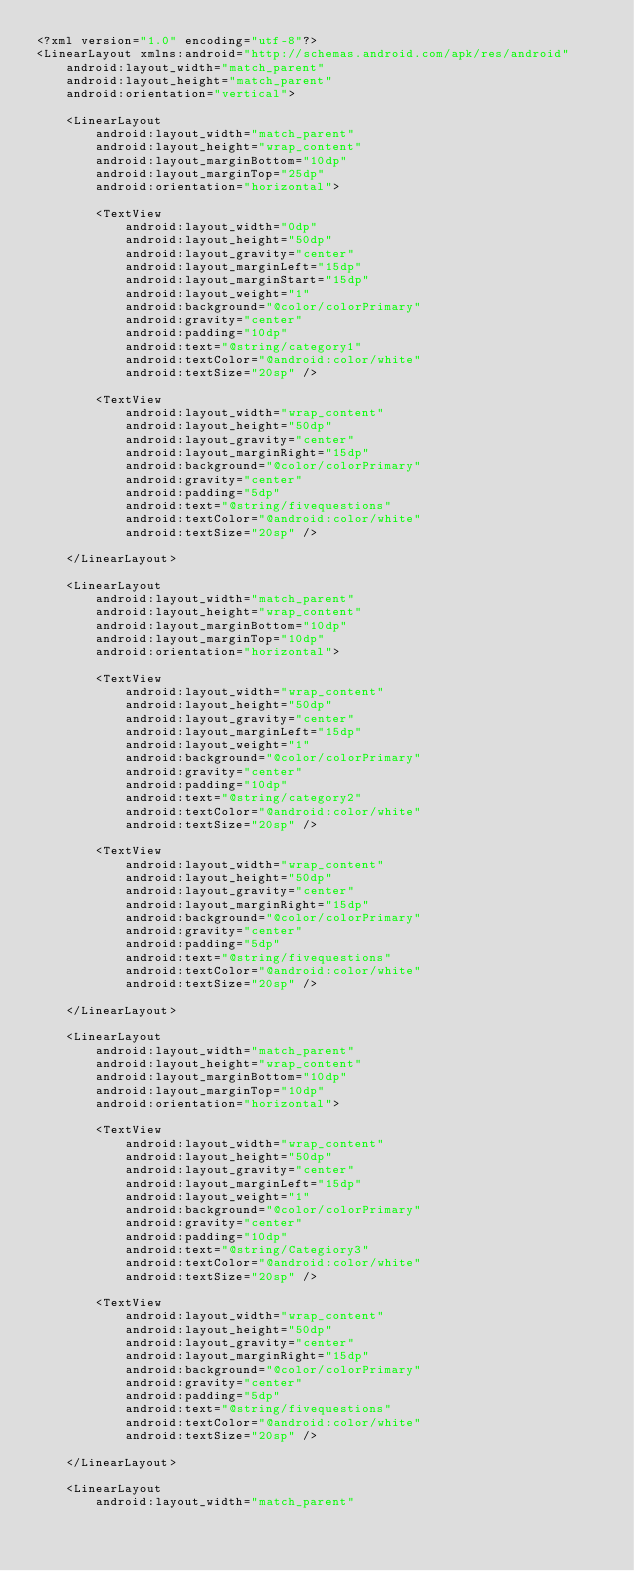<code> <loc_0><loc_0><loc_500><loc_500><_XML_><?xml version="1.0" encoding="utf-8"?>
<LinearLayout xmlns:android="http://schemas.android.com/apk/res/android"
    android:layout_width="match_parent"
    android:layout_height="match_parent"
    android:orientation="vertical">

    <LinearLayout
        android:layout_width="match_parent"
        android:layout_height="wrap_content"
        android:layout_marginBottom="10dp"
        android:layout_marginTop="25dp"
        android:orientation="horizontal">

        <TextView
            android:layout_width="0dp"
            android:layout_height="50dp"
            android:layout_gravity="center"
            android:layout_marginLeft="15dp"
            android:layout_marginStart="15dp"
            android:layout_weight="1"
            android:background="@color/colorPrimary"
            android:gravity="center"
            android:padding="10dp"
            android:text="@string/category1"
            android:textColor="@android:color/white"
            android:textSize="20sp" />

        <TextView
            android:layout_width="wrap_content"
            android:layout_height="50dp"
            android:layout_gravity="center"
            android:layout_marginRight="15dp"
            android:background="@color/colorPrimary"
            android:gravity="center"
            android:padding="5dp"
            android:text="@string/fivequestions"
            android:textColor="@android:color/white"
            android:textSize="20sp" />

    </LinearLayout>

    <LinearLayout
        android:layout_width="match_parent"
        android:layout_height="wrap_content"
        android:layout_marginBottom="10dp"
        android:layout_marginTop="10dp"
        android:orientation="horizontal">

        <TextView
            android:layout_width="wrap_content"
            android:layout_height="50dp"
            android:layout_gravity="center"
            android:layout_marginLeft="15dp"
            android:layout_weight="1"
            android:background="@color/colorPrimary"
            android:gravity="center"
            android:padding="10dp"
            android:text="@string/category2"
            android:textColor="@android:color/white"
            android:textSize="20sp" />

        <TextView
            android:layout_width="wrap_content"
            android:layout_height="50dp"
            android:layout_gravity="center"
            android:layout_marginRight="15dp"
            android:background="@color/colorPrimary"
            android:gravity="center"
            android:padding="5dp"
            android:text="@string/fivequestions"
            android:textColor="@android:color/white"
            android:textSize="20sp" />

    </LinearLayout>

    <LinearLayout
        android:layout_width="match_parent"
        android:layout_height="wrap_content"
        android:layout_marginBottom="10dp"
        android:layout_marginTop="10dp"
        android:orientation="horizontal">

        <TextView
            android:layout_width="wrap_content"
            android:layout_height="50dp"
            android:layout_gravity="center"
            android:layout_marginLeft="15dp"
            android:layout_weight="1"
            android:background="@color/colorPrimary"
            android:gravity="center"
            android:padding="10dp"
            android:text="@string/Categiory3"
            android:textColor="@android:color/white"
            android:textSize="20sp" />

        <TextView
            android:layout_width="wrap_content"
            android:layout_height="50dp"
            android:layout_gravity="center"
            android:layout_marginRight="15dp"
            android:background="@color/colorPrimary"
            android:gravity="center"
            android:padding="5dp"
            android:text="@string/fivequestions"
            android:textColor="@android:color/white"
            android:textSize="20sp" />

    </LinearLayout>

    <LinearLayout
        android:layout_width="match_parent"</code> 